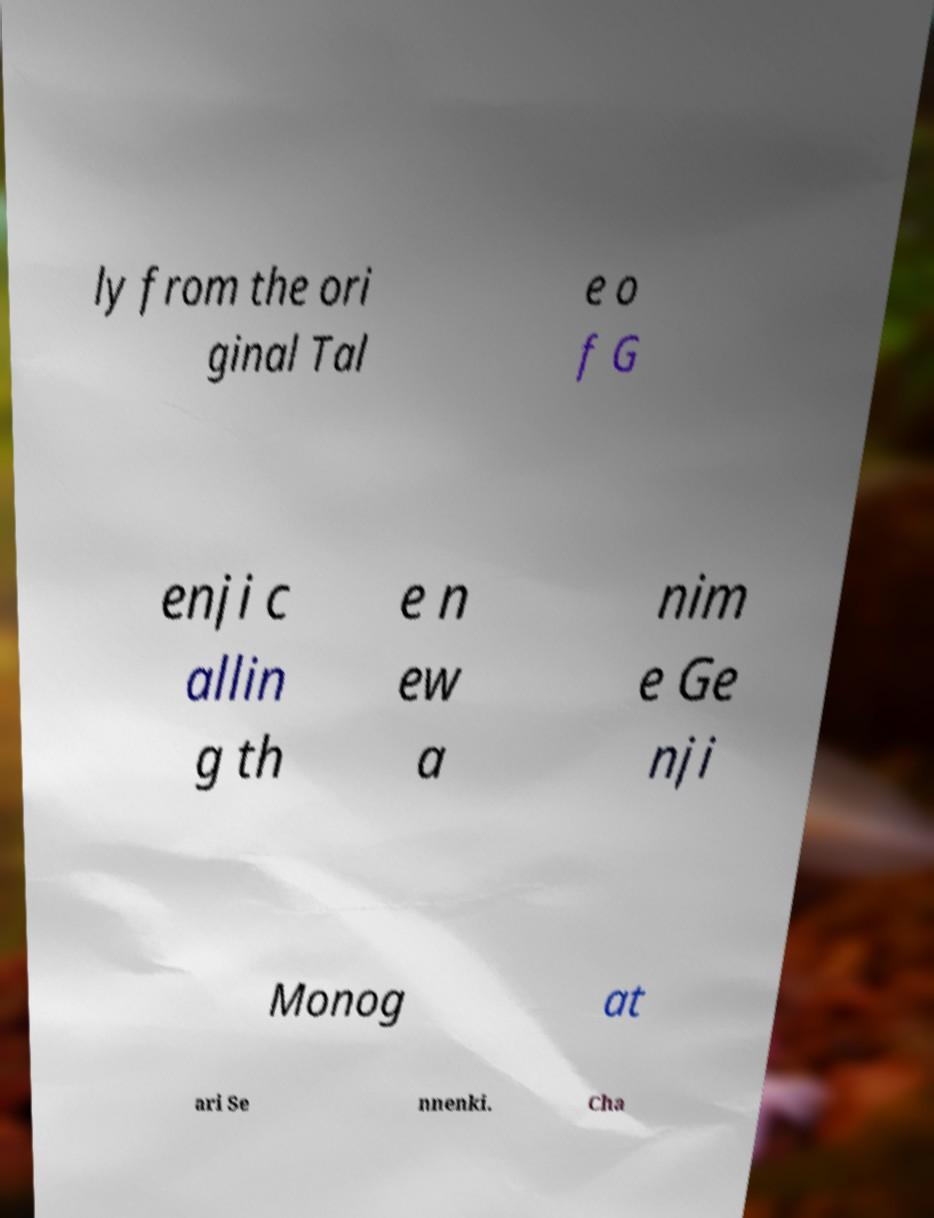Can you read and provide the text displayed in the image?This photo seems to have some interesting text. Can you extract and type it out for me? ly from the ori ginal Tal e o f G enji c allin g th e n ew a nim e Ge nji Monog at ari Se nnenki. Cha 